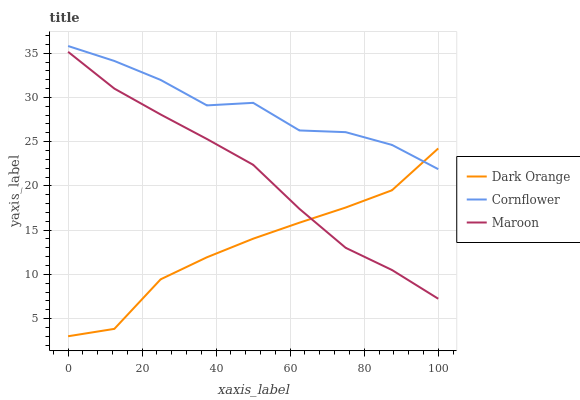Does Dark Orange have the minimum area under the curve?
Answer yes or no. Yes. Does Maroon have the minimum area under the curve?
Answer yes or no. No. Does Maroon have the maximum area under the curve?
Answer yes or no. No. Is Cornflower the smoothest?
Answer yes or no. No. Is Maroon the roughest?
Answer yes or no. No. Does Maroon have the lowest value?
Answer yes or no. No. Does Maroon have the highest value?
Answer yes or no. No. Is Maroon less than Cornflower?
Answer yes or no. Yes. Is Cornflower greater than Maroon?
Answer yes or no. Yes. Does Maroon intersect Cornflower?
Answer yes or no. No. 